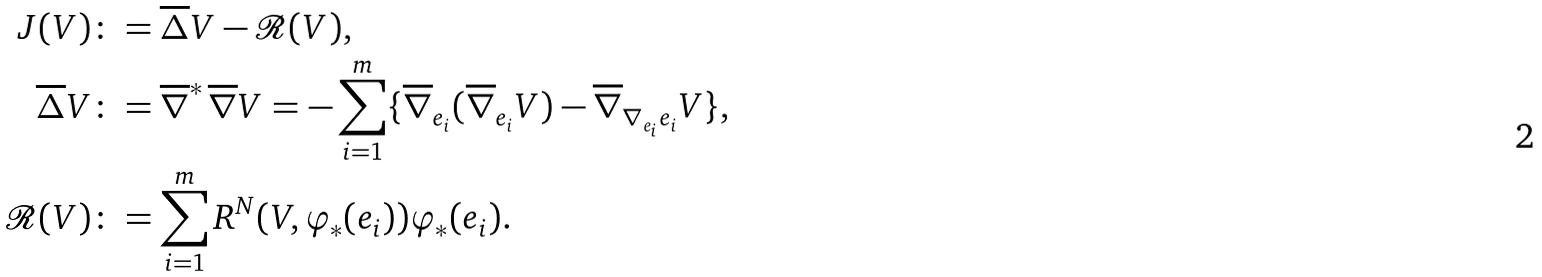<formula> <loc_0><loc_0><loc_500><loc_500>J ( V ) & \colon = \overline { \Delta } V - { \mathcal { R } } ( V ) , \\ \overline { \Delta } V & \colon = { \overline { \nabla } } ^ { \ast } \, { \overline { \nabla } } V = - \sum _ { i = 1 } ^ { m } \{ { \overline { \nabla } } _ { e _ { i } } ( { \overline { \nabla } } _ { e _ { i } } V ) - { \overline { \nabla } } _ { \nabla _ { e _ { i } } e _ { i } } V \} , \\ { \mathcal { R } } ( V ) & \colon = \sum _ { i = 1 } ^ { m } R ^ { N } ( V , \varphi _ { \ast } ( e _ { i } ) ) \varphi _ { \ast } ( e _ { i } ) .</formula> 